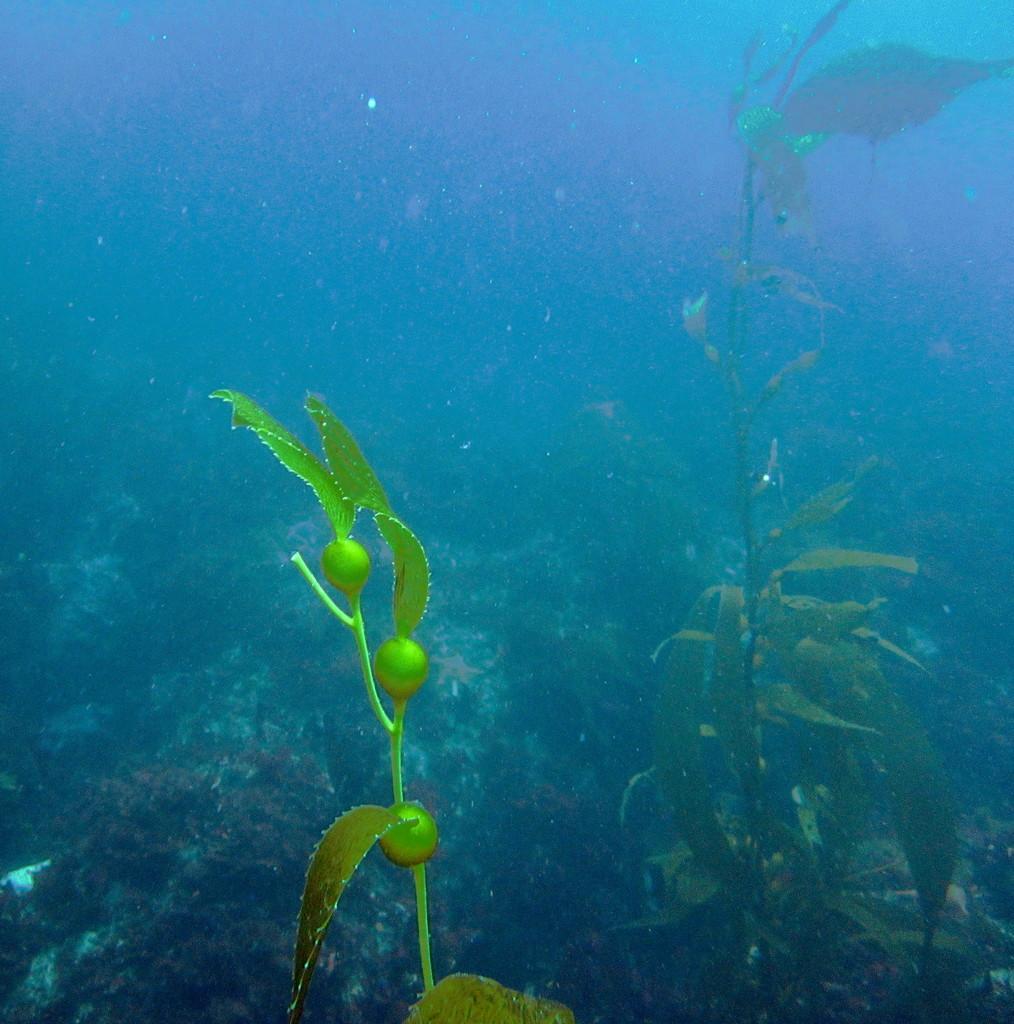Can you describe this image briefly? In this picture I can see the inside view of the water and I can see the plants in front. 